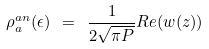<formula> <loc_0><loc_0><loc_500><loc_500>\rho _ { a } ^ { a n } ( \epsilon ) \ = \ \frac { 1 } { 2 \sqrt { \pi P } } R e ( w ( z ) )</formula> 